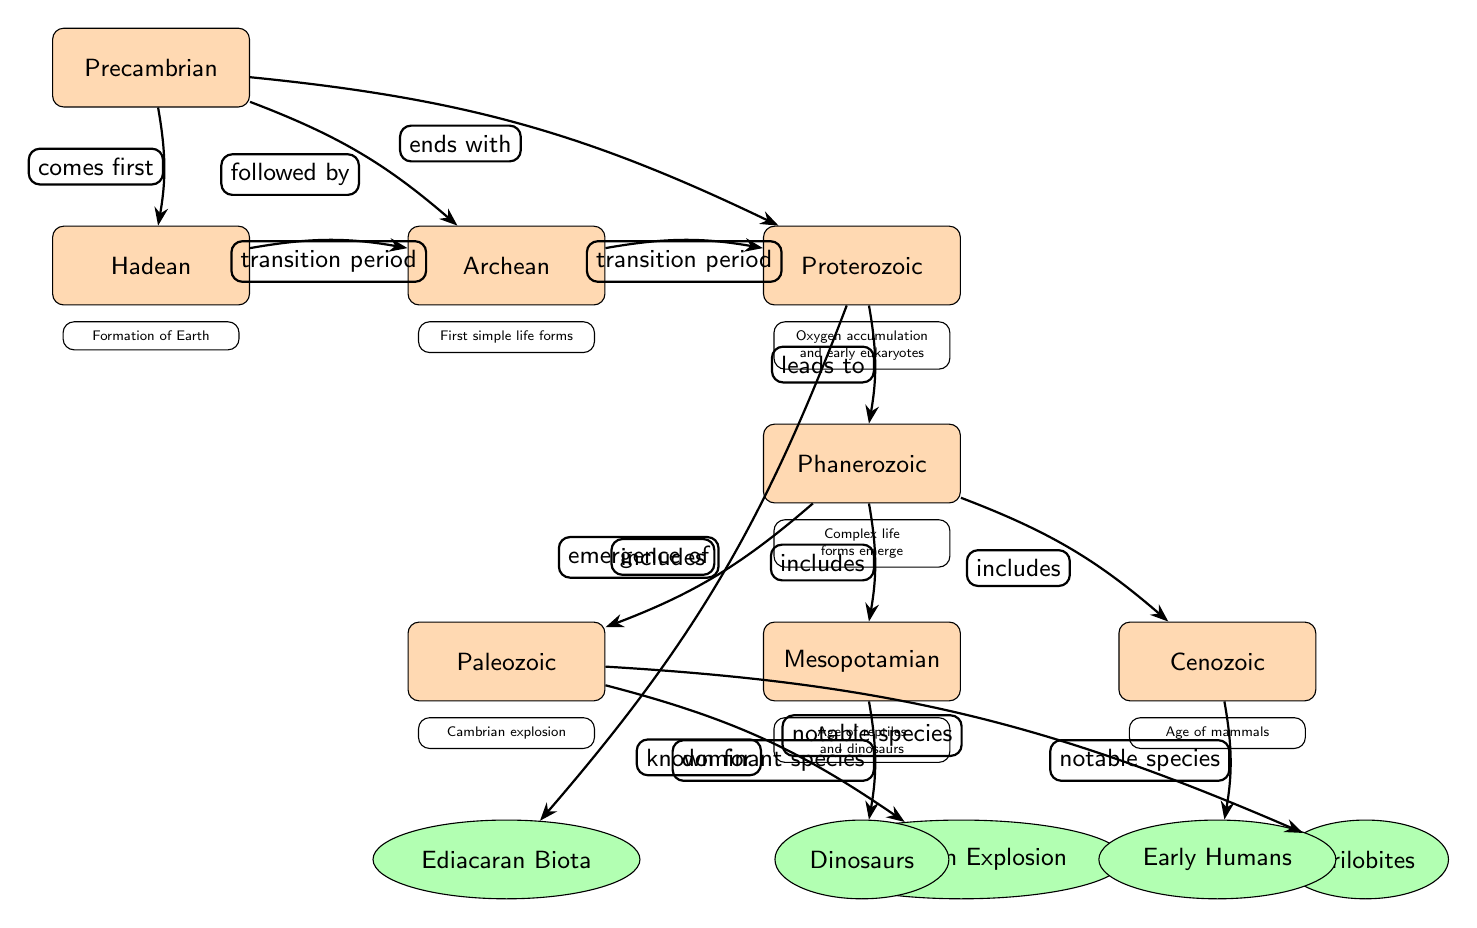What is the first era in the diagram? The diagram lists the eras starting with the Precambrian at the top, indicating it is the first era.
Answer: Precambrian Which species are associated with the Paleozoic era? The diagram shows the connections from the Paleozoic era to the Cambrian Explosion and Trilobites, which are both notable species linked to this era.
Answer: Cambrian Explosion, Trilobites What does the Mesopotamian era include? In the diagram, the Mesopotamian era has a connection labeled 'dominant species' leading to Dinosaurs, indicating that Dinosaurs are a notable part of this era.
Answer: Dinosaurs How many distinct eras are depicted in the diagram? By counting the eras listed in the diagram, we see there are a total of seven distinct eras.
Answer: 7 Which species emerges during the Proterozoic era? The diagram indicates that the Proterozoic era leads to the emergence of the Ediacaran Biota, showing the connection labeled ‘emergence of’.
Answer: Ediacaran Biota What transition occurs between the Hadean and Archean eras? The diagram includes the label 'transition period' connecting Hadean to Archean, indicating a significant change between these eras.
Answer: transition period How is the Phanerozoic era characterized in the diagram? The Phanerozoic era is indicated as encompassing complex life forms with connections to other major eras, highlighting its importance in the evolutionary timeline.
Answer: Complex life forms emerge Which era is noted for the age of mammals? The diagram specifies that the Cenozoic era is recognized as the Age of Mammals, as described under it.
Answer: Cenozoic 